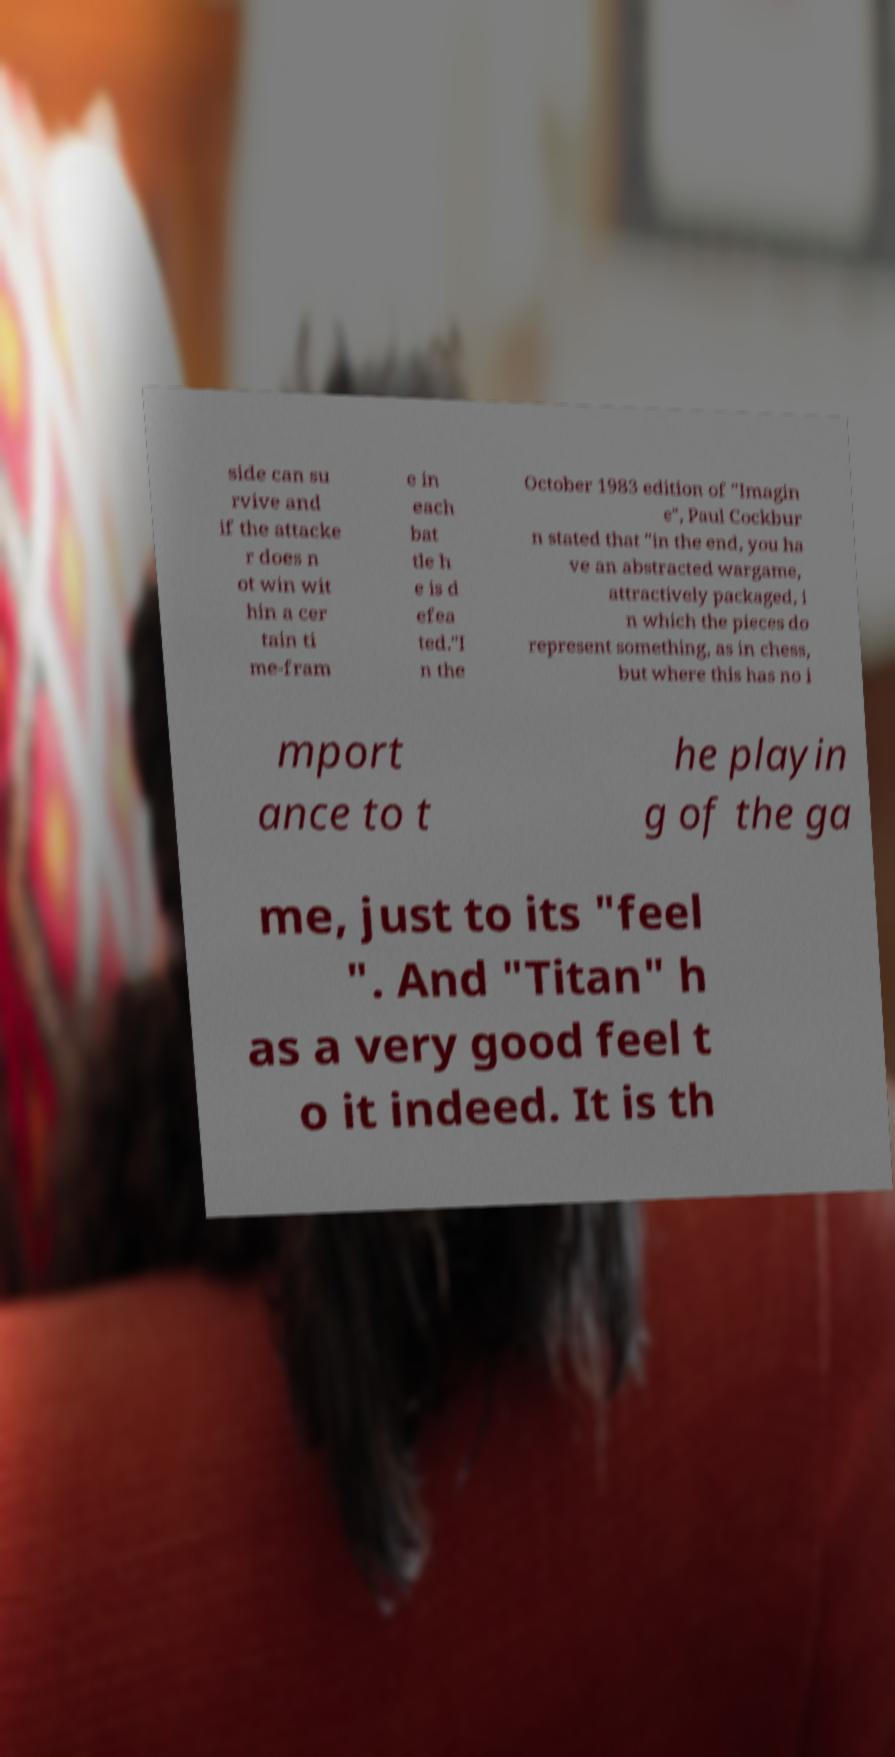Can you accurately transcribe the text from the provided image for me? side can su rvive and if the attacke r does n ot win wit hin a cer tain ti me-fram e in each bat tle h e is d efea ted."I n the October 1983 edition of "Imagin e", Paul Cockbur n stated that "in the end, you ha ve an abstracted wargame, attractively packaged, i n which the pieces do represent something, as in chess, but where this has no i mport ance to t he playin g of the ga me, just to its "feel ". And "Titan" h as a very good feel t o it indeed. It is th 